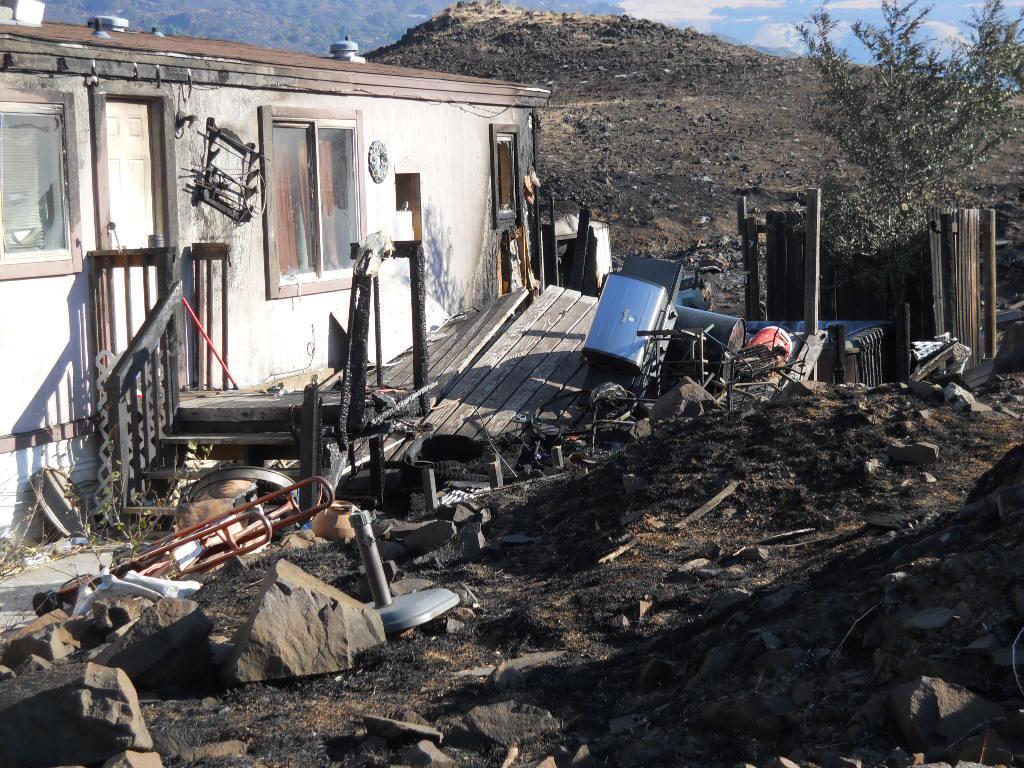Please provide a concise description of this image. This image is taken outdoors. In the background there are a few hills and there is the sky with clouds. On the left side of the image there is a house with walls, windows, doors and a roof. There are many iron bars and a few collapsed wooden platforms. There are many stones and rocks on the ground. There are many objects. There is a wooden fence and there is a tree. 